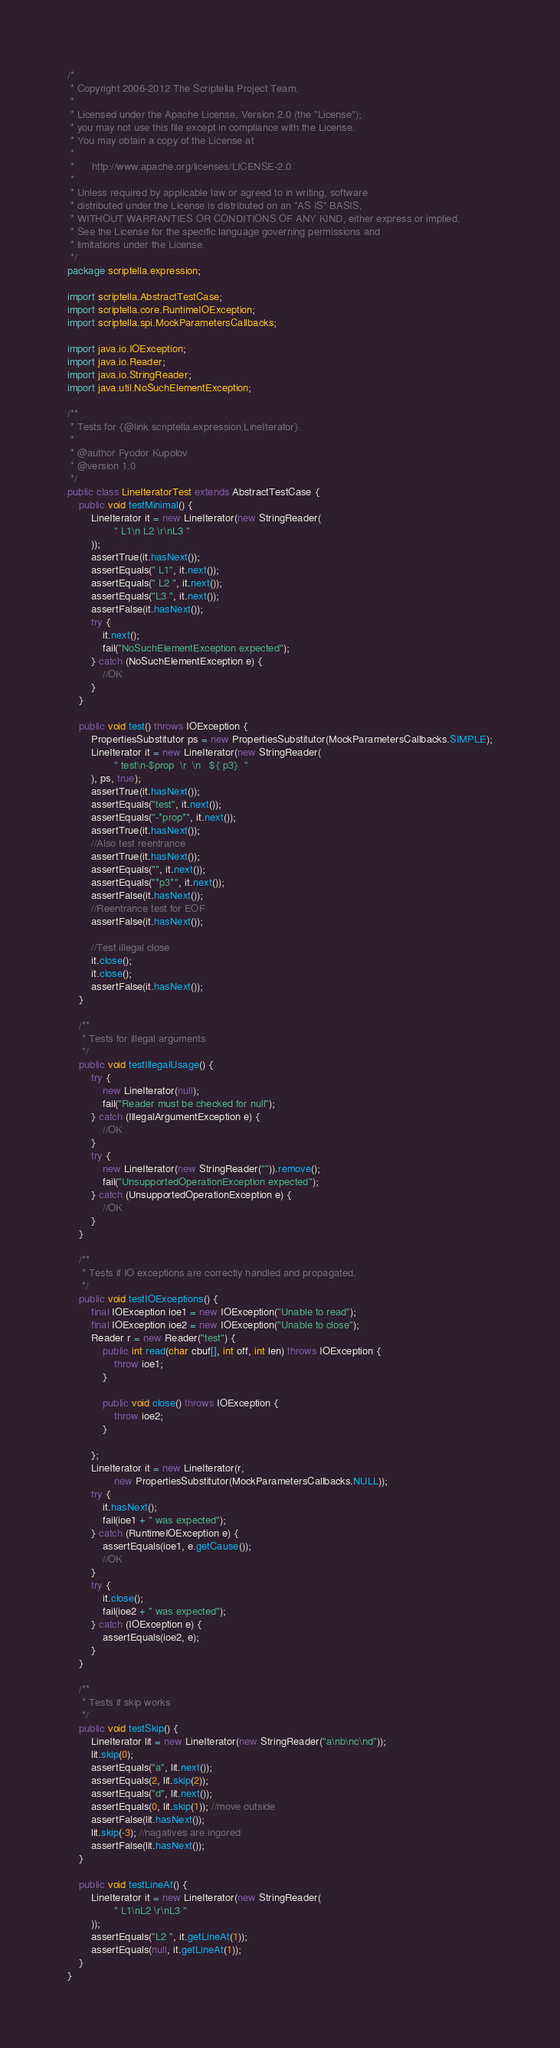Convert code to text. <code><loc_0><loc_0><loc_500><loc_500><_Java_>/*
 * Copyright 2006-2012 The Scriptella Project Team.
 *
 * Licensed under the Apache License, Version 2.0 (the "License");
 * you may not use this file except in compliance with the License.
 * You may obtain a copy of the License at
 *
 *      http://www.apache.org/licenses/LICENSE-2.0
 *
 * Unless required by applicable law or agreed to in writing, software
 * distributed under the License is distributed on an "AS IS" BASIS,
 * WITHOUT WARRANTIES OR CONDITIONS OF ANY KIND, either express or implied.
 * See the License for the specific language governing permissions and
 * limitations under the License.
 */
package scriptella.expression;

import scriptella.AbstractTestCase;
import scriptella.core.RuntimeIOException;
import scriptella.spi.MockParametersCallbacks;

import java.io.IOException;
import java.io.Reader;
import java.io.StringReader;
import java.util.NoSuchElementException;

/**
 * Tests for {@link scriptella.expression.LineIterator}.
 *
 * @author Fyodor Kupolov
 * @version 1.0
 */
public class LineIteratorTest extends AbstractTestCase {
    public void testMinimal() {
        LineIterator it = new LineIterator(new StringReader(
                " L1\n L2 \r\nL3 "
        ));
        assertTrue(it.hasNext());
        assertEquals(" L1", it.next());
        assertEquals(" L2 ", it.next());
        assertEquals("L3 ", it.next());
        assertFalse(it.hasNext());
        try {
            it.next();
            fail("NoSuchElementException expected");
        } catch (NoSuchElementException e) {
            //OK
        }
    }

    public void test() throws IOException {
        PropertiesSubstitutor ps = new PropertiesSubstitutor(MockParametersCallbacks.SIMPLE);
        LineIterator it = new LineIterator(new StringReader(
                " test\n-$prop  \r  \n   ${ p3}  "
        ), ps, true);
        assertTrue(it.hasNext());
        assertEquals("test", it.next());
        assertEquals("-*prop*", it.next());
        assertTrue(it.hasNext());
        //Also test reentrance
        assertTrue(it.hasNext());
        assertEquals("", it.next());
        assertEquals("*p3*", it.next());
        assertFalse(it.hasNext());
        //Reentrance test for EOF
        assertFalse(it.hasNext());

        //Test illegal close
        it.close();
        it.close();
        assertFalse(it.hasNext());
    }

    /**
     * Tests for illegal arguments
     */
    public void testIllegalUsage() {
        try {
            new LineIterator(null);
            fail("Reader must be checked for null");
        } catch (IllegalArgumentException e) {
            //OK
        }
        try {
            new LineIterator(new StringReader("")).remove();
            fail("UnsupportedOperationException expected");
        } catch (UnsupportedOperationException e) {
            //OK
        }
    }

    /**
     * Tests if IO exceptions are correctly handled and propagated.
     */
    public void testIOExceptions() {
        final IOException ioe1 = new IOException("Unable to read");
        final IOException ioe2 = new IOException("Unable to close");
        Reader r = new Reader("test") {
            public int read(char cbuf[], int off, int len) throws IOException {
                throw ioe1;
            }

            public void close() throws IOException {
                throw ioe2;
            }

        };
        LineIterator it = new LineIterator(r,
                new PropertiesSubstitutor(MockParametersCallbacks.NULL));
        try {
            it.hasNext();
            fail(ioe1 + " was expected");
        } catch (RuntimeIOException e) {
            assertEquals(ioe1, e.getCause());
            //OK
        }
        try {
            it.close();
            fail(ioe2 + " was expected");
        } catch (IOException e) {
            assertEquals(ioe2, e);
        }
    }

    /**
     * Tests if skip works
     */
    public void testSkip() {
        LineIterator lit = new LineIterator(new StringReader("a\nb\nc\nd"));
        lit.skip(0);
        assertEquals("a", lit.next());
        assertEquals(2, lit.skip(2));
        assertEquals("d", lit.next());
        assertEquals(0, lit.skip(1)); //move outside
        assertFalse(lit.hasNext());
        lit.skip(-3); //nagatives are ingored
        assertFalse(lit.hasNext());
    }

    public void testLineAt() {
        LineIterator it = new LineIterator(new StringReader(
                " L1\nL2 \r\nL3 "
        ));
        assertEquals("L2 ", it.getLineAt(1));
        assertEquals(null, it.getLineAt(1));
    }
}
</code> 